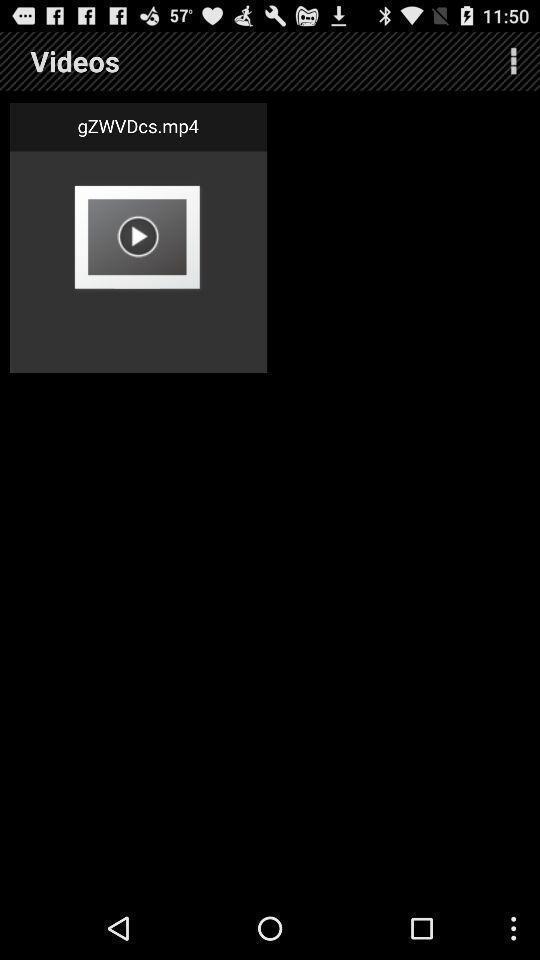Provide a detailed account of this screenshot. Page displaying a video in the app. 